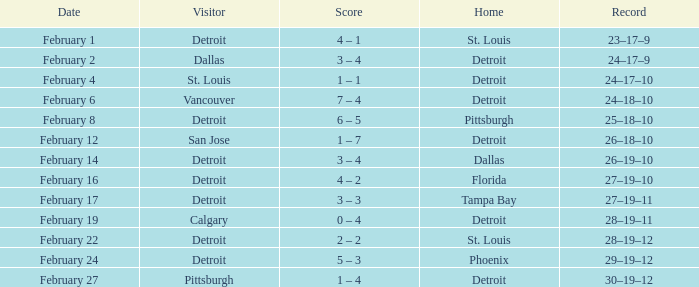What was their performance when they were at pittsburgh? 25–18–10. 